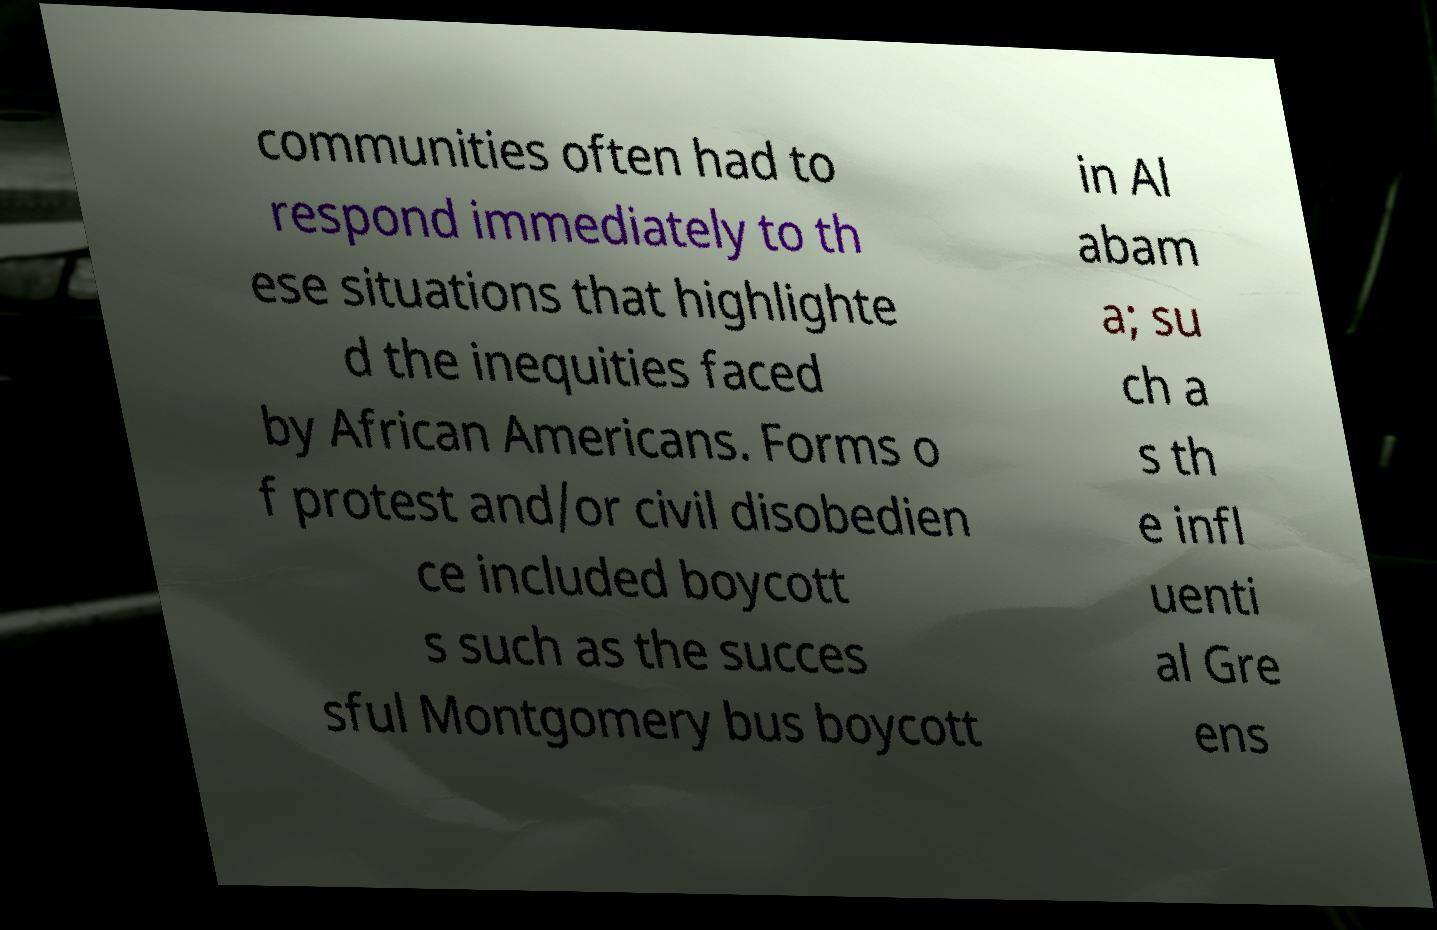Could you extract and type out the text from this image? communities often had to respond immediately to th ese situations that highlighte d the inequities faced by African Americans. Forms o f protest and/or civil disobedien ce included boycott s such as the succes sful Montgomery bus boycott in Al abam a; su ch a s th e infl uenti al Gre ens 